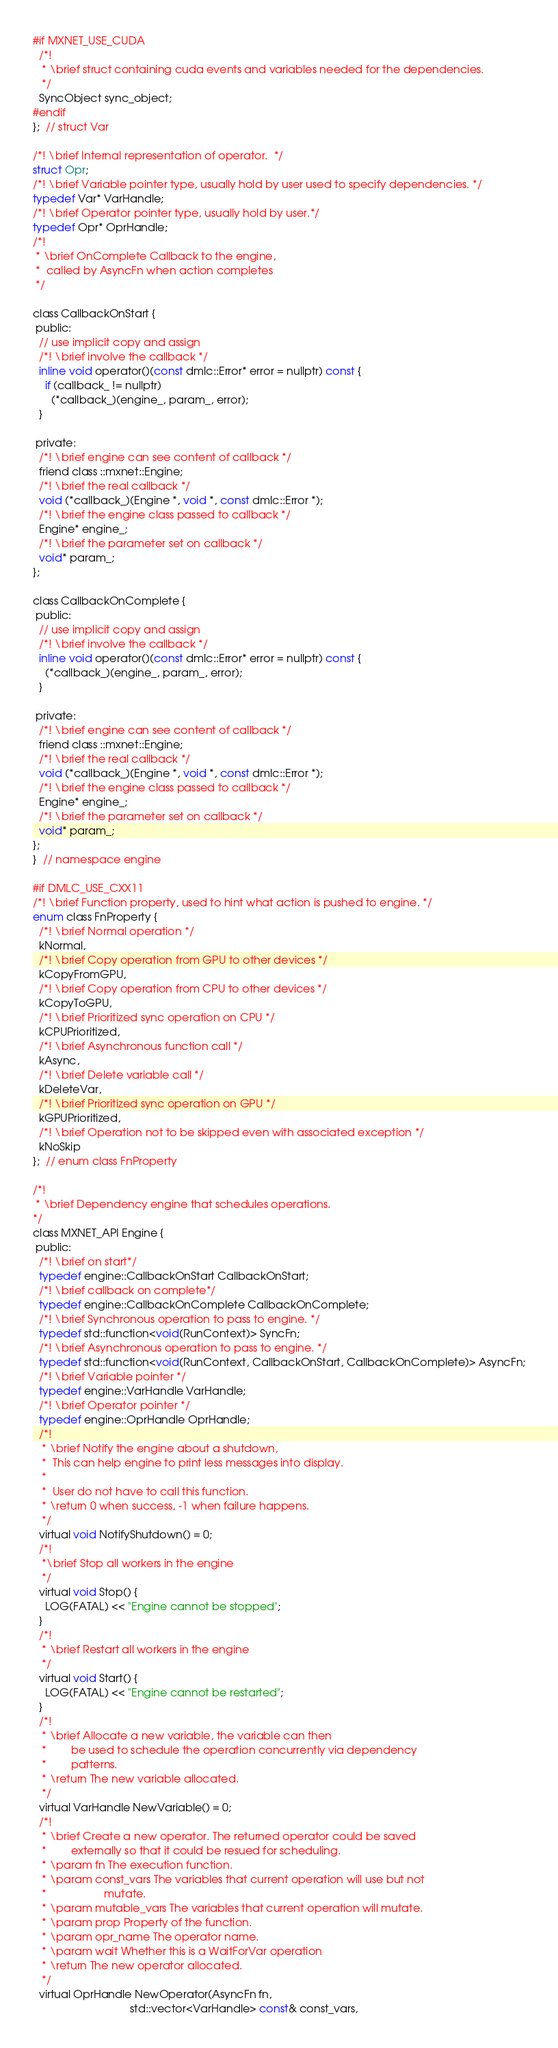Convert code to text. <code><loc_0><loc_0><loc_500><loc_500><_C_>#if MXNET_USE_CUDA
  /*!
   * \brief struct containing cuda events and variables needed for the dependencies.
   */
  SyncObject sync_object;
#endif
};  // struct Var

/*! \brief Internal representation of operator.  */
struct Opr;
/*! \brief Variable pointer type, usually hold by user used to specify dependencies. */
typedef Var* VarHandle;
/*! \brief Operator pointer type, usually hold by user.*/
typedef Opr* OprHandle;
/*!
 * \brief OnComplete Callback to the engine,
 *  called by AsyncFn when action completes
 */

class CallbackOnStart {
 public:
  // use implicit copy and assign
  /*! \brief involve the callback */
  inline void operator()(const dmlc::Error* error = nullptr) const {
    if (callback_ != nullptr)
      (*callback_)(engine_, param_, error);
  }

 private:
  /*! \brief engine can see content of callback */
  friend class ::mxnet::Engine;
  /*! \brief the real callback */
  void (*callback_)(Engine *, void *, const dmlc::Error *);
  /*! \brief the engine class passed to callback */
  Engine* engine_;
  /*! \brief the parameter set on callback */
  void* param_;
};

class CallbackOnComplete {
 public:
  // use implicit copy and assign
  /*! \brief involve the callback */
  inline void operator()(const dmlc::Error* error = nullptr) const {
    (*callback_)(engine_, param_, error);
  }

 private:
  /*! \brief engine can see content of callback */
  friend class ::mxnet::Engine;
  /*! \brief the real callback */
  void (*callback_)(Engine *, void *, const dmlc::Error *);
  /*! \brief the engine class passed to callback */
  Engine* engine_;
  /*! \brief the parameter set on callback */
  void* param_;
};
}  // namespace engine

#if DMLC_USE_CXX11
/*! \brief Function property, used to hint what action is pushed to engine. */
enum class FnProperty {
  /*! \brief Normal operation */
  kNormal,
  /*! \brief Copy operation from GPU to other devices */
  kCopyFromGPU,
  /*! \brief Copy operation from CPU to other devices */
  kCopyToGPU,
  /*! \brief Prioritized sync operation on CPU */
  kCPUPrioritized,
  /*! \brief Asynchronous function call */
  kAsync,
  /*! \brief Delete variable call */
  kDeleteVar,
  /*! \brief Prioritized sync operation on GPU */
  kGPUPrioritized,
  /*! \brief Operation not to be skipped even with associated exception */
  kNoSkip
};  // enum class FnProperty

/*!
 * \brief Dependency engine that schedules operations.
*/
class MXNET_API Engine {
 public:
  /*! \brief on start*/
  typedef engine::CallbackOnStart CallbackOnStart;
  /*! \brief callback on complete*/
  typedef engine::CallbackOnComplete CallbackOnComplete;
  /*! \brief Synchronous operation to pass to engine. */
  typedef std::function<void(RunContext)> SyncFn;
  /*! \brief Asynchronous operation to pass to engine. */
  typedef std::function<void(RunContext, CallbackOnStart, CallbackOnComplete)> AsyncFn;
  /*! \brief Variable pointer */
  typedef engine::VarHandle VarHandle;
  /*! \brief Operator pointer */
  typedef engine::OprHandle OprHandle;
  /*!
   * \brief Notify the engine about a shutdown,
   *  This can help engine to print less messages into display.
   *
   *  User do not have to call this function.
   * \return 0 when success, -1 when failure happens.
   */
  virtual void NotifyShutdown() = 0;
  /*!
   *\brief Stop all workers in the engine
   */
  virtual void Stop() {
    LOG(FATAL) << "Engine cannot be stopped";
  }
  /*!
   * \brief Restart all workers in the engine
   */
  virtual void Start() {
    LOG(FATAL) << "Engine cannot be restarted";
  }
  /*!
   * \brief Allocate a new variable, the variable can then
   *        be used to schedule the operation concurrently via dependency
   *        patterns.
   * \return The new variable allocated.
   */
  virtual VarHandle NewVariable() = 0;
  /*!
   * \brief Create a new operator. The returned operator could be saved
   *        externally so that it could be resued for scheduling.
   * \param fn The execution function.
   * \param const_vars The variables that current operation will use but not
   *                   mutate.
   * \param mutable_vars The variables that current operation will mutate.
   * \param prop Property of the function.
   * \param opr_name The operator name.
   * \param wait Whether this is a WaitForVar operation
   * \return The new operator allocated.
   */
  virtual OprHandle NewOperator(AsyncFn fn,
                                std::vector<VarHandle> const& const_vars,</code> 